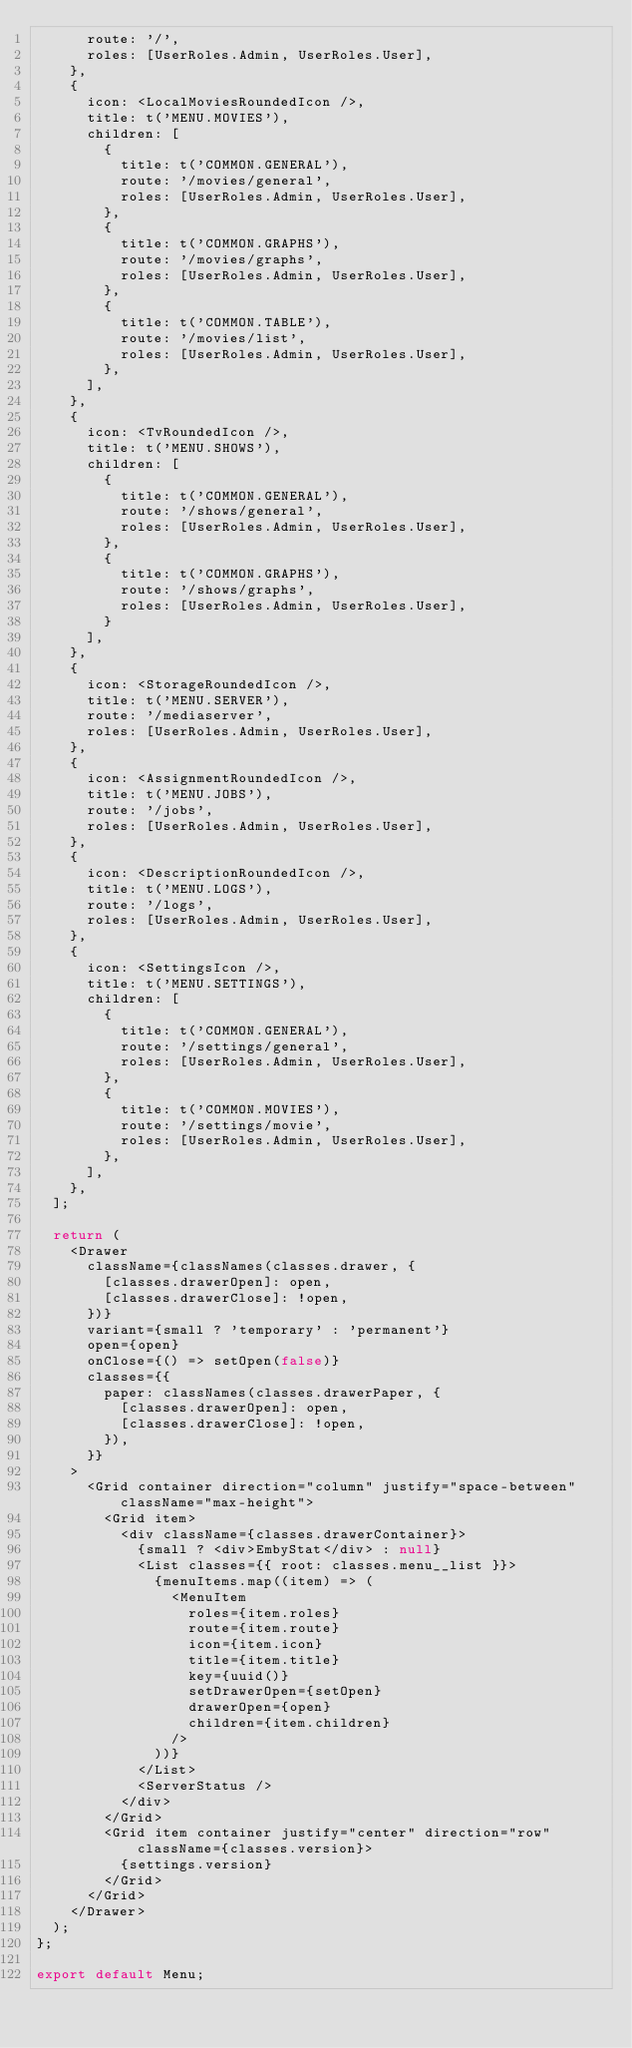<code> <loc_0><loc_0><loc_500><loc_500><_TypeScript_>      route: '/',
      roles: [UserRoles.Admin, UserRoles.User],
    },
    {
      icon: <LocalMoviesRoundedIcon />,
      title: t('MENU.MOVIES'),
      children: [
        {
          title: t('COMMON.GENERAL'),
          route: '/movies/general',
          roles: [UserRoles.Admin, UserRoles.User],
        },
        {
          title: t('COMMON.GRAPHS'),
          route: '/movies/graphs',
          roles: [UserRoles.Admin, UserRoles.User],
        },
        {
          title: t('COMMON.TABLE'),
          route: '/movies/list',
          roles: [UserRoles.Admin, UserRoles.User],
        },
      ],
    },
    {
      icon: <TvRoundedIcon />,
      title: t('MENU.SHOWS'),
      children: [
        {
          title: t('COMMON.GENERAL'),
          route: '/shows/general',
          roles: [UserRoles.Admin, UserRoles.User],
        },
        {
          title: t('COMMON.GRAPHS'),
          route: '/shows/graphs',
          roles: [UserRoles.Admin, UserRoles.User],
        }
      ],
    },
    {
      icon: <StorageRoundedIcon />,
      title: t('MENU.SERVER'),
      route: '/mediaserver',
      roles: [UserRoles.Admin, UserRoles.User],
    },
    {
      icon: <AssignmentRoundedIcon />,
      title: t('MENU.JOBS'),
      route: '/jobs',
      roles: [UserRoles.Admin, UserRoles.User],
    },
    {
      icon: <DescriptionRoundedIcon />,
      title: t('MENU.LOGS'),
      route: '/logs',
      roles: [UserRoles.Admin, UserRoles.User],
    },
    {
      icon: <SettingsIcon />,
      title: t('MENU.SETTINGS'),
      children: [
        {
          title: t('COMMON.GENERAL'),
          route: '/settings/general',
          roles: [UserRoles.Admin, UserRoles.User],
        },
        {
          title: t('COMMON.MOVIES'),
          route: '/settings/movie',
          roles: [UserRoles.Admin, UserRoles.User],
        },
      ],
    },
  ];

  return (
    <Drawer
      className={classNames(classes.drawer, {
        [classes.drawerOpen]: open,
        [classes.drawerClose]: !open,
      })}
      variant={small ? 'temporary' : 'permanent'}
      open={open}
      onClose={() => setOpen(false)}
      classes={{
        paper: classNames(classes.drawerPaper, {
          [classes.drawerOpen]: open,
          [classes.drawerClose]: !open,
        }),
      }}
    >
      <Grid container direction="column" justify="space-between" className="max-height">
        <Grid item>
          <div className={classes.drawerContainer}>
            {small ? <div>EmbyStat</div> : null}
            <List classes={{ root: classes.menu__list }}>
              {menuItems.map((item) => (
                <MenuItem
                  roles={item.roles}
                  route={item.route}
                  icon={item.icon}
                  title={item.title}
                  key={uuid()}
                  setDrawerOpen={setOpen}
                  drawerOpen={open}
                  children={item.children}
                />
              ))}
            </List>
            <ServerStatus />
          </div>
        </Grid>
        <Grid item container justify="center" direction="row" className={classes.version}>
          {settings.version}
        </Grid>
      </Grid>
    </Drawer>
  );
};

export default Menu;
</code> 